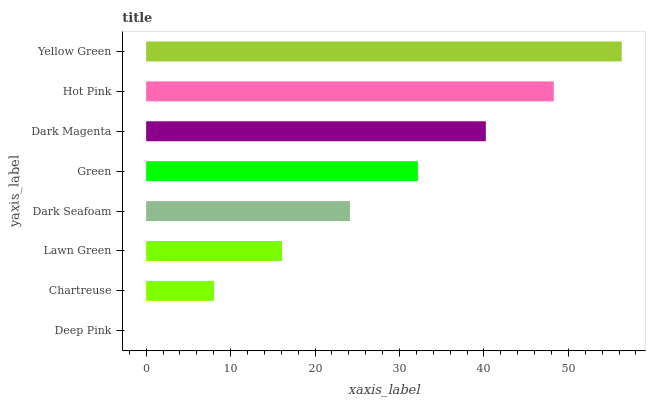Is Deep Pink the minimum?
Answer yes or no. Yes. Is Yellow Green the maximum?
Answer yes or no. Yes. Is Chartreuse the minimum?
Answer yes or no. No. Is Chartreuse the maximum?
Answer yes or no. No. Is Chartreuse greater than Deep Pink?
Answer yes or no. Yes. Is Deep Pink less than Chartreuse?
Answer yes or no. Yes. Is Deep Pink greater than Chartreuse?
Answer yes or no. No. Is Chartreuse less than Deep Pink?
Answer yes or no. No. Is Green the high median?
Answer yes or no. Yes. Is Dark Seafoam the low median?
Answer yes or no. Yes. Is Deep Pink the high median?
Answer yes or no. No. Is Hot Pink the low median?
Answer yes or no. No. 